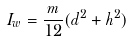Convert formula to latex. <formula><loc_0><loc_0><loc_500><loc_500>I _ { w } = \frac { m } { 1 2 } ( d ^ { 2 } + h ^ { 2 } )</formula> 